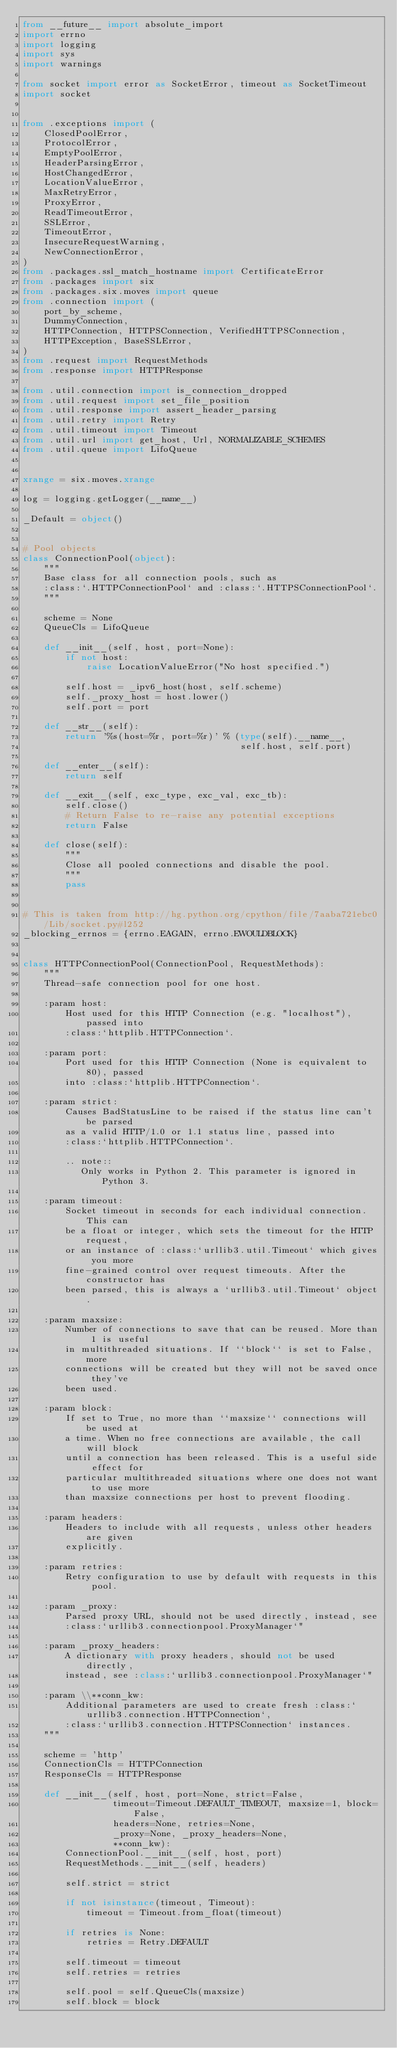<code> <loc_0><loc_0><loc_500><loc_500><_Python_>from __future__ import absolute_import
import errno
import logging
import sys
import warnings

from socket import error as SocketError, timeout as SocketTimeout
import socket


from .exceptions import (
    ClosedPoolError,
    ProtocolError,
    EmptyPoolError,
    HeaderParsingError,
    HostChangedError,
    LocationValueError,
    MaxRetryError,
    ProxyError,
    ReadTimeoutError,
    SSLError,
    TimeoutError,
    InsecureRequestWarning,
    NewConnectionError,
)
from .packages.ssl_match_hostname import CertificateError
from .packages import six
from .packages.six.moves import queue
from .connection import (
    port_by_scheme,
    DummyConnection,
    HTTPConnection, HTTPSConnection, VerifiedHTTPSConnection,
    HTTPException, BaseSSLError,
)
from .request import RequestMethods
from .response import HTTPResponse

from .util.connection import is_connection_dropped
from .util.request import set_file_position
from .util.response import assert_header_parsing
from .util.retry import Retry
from .util.timeout import Timeout
from .util.url import get_host, Url, NORMALIZABLE_SCHEMES
from .util.queue import LifoQueue


xrange = six.moves.xrange

log = logging.getLogger(__name__)

_Default = object()


# Pool objects
class ConnectionPool(object):
    """
    Base class for all connection pools, such as
    :class:`.HTTPConnectionPool` and :class:`.HTTPSConnectionPool`.
    """

    scheme = None
    QueueCls = LifoQueue

    def __init__(self, host, port=None):
        if not host:
            raise LocationValueError("No host specified.")

        self.host = _ipv6_host(host, self.scheme)
        self._proxy_host = host.lower()
        self.port = port

    def __str__(self):
        return '%s(host=%r, port=%r)' % (type(self).__name__,
                                         self.host, self.port)

    def __enter__(self):
        return self

    def __exit__(self, exc_type, exc_val, exc_tb):
        self.close()
        # Return False to re-raise any potential exceptions
        return False

    def close(self):
        """
        Close all pooled connections and disable the pool.
        """
        pass


# This is taken from http://hg.python.org/cpython/file/7aaba721ebc0/Lib/socket.py#l252
_blocking_errnos = {errno.EAGAIN, errno.EWOULDBLOCK}


class HTTPConnectionPool(ConnectionPool, RequestMethods):
    """
    Thread-safe connection pool for one host.

    :param host:
        Host used for this HTTP Connection (e.g. "localhost"), passed into
        :class:`httplib.HTTPConnection`.

    :param port:
        Port used for this HTTP Connection (None is equivalent to 80), passed
        into :class:`httplib.HTTPConnection`.

    :param strict:
        Causes BadStatusLine to be raised if the status line can't be parsed
        as a valid HTTP/1.0 or 1.1 status line, passed into
        :class:`httplib.HTTPConnection`.

        .. note::
           Only works in Python 2. This parameter is ignored in Python 3.

    :param timeout:
        Socket timeout in seconds for each individual connection. This can
        be a float or integer, which sets the timeout for the HTTP request,
        or an instance of :class:`urllib3.util.Timeout` which gives you more
        fine-grained control over request timeouts. After the constructor has
        been parsed, this is always a `urllib3.util.Timeout` object.

    :param maxsize:
        Number of connections to save that can be reused. More than 1 is useful
        in multithreaded situations. If ``block`` is set to False, more
        connections will be created but they will not be saved once they've
        been used.

    :param block:
        If set to True, no more than ``maxsize`` connections will be used at
        a time. When no free connections are available, the call will block
        until a connection has been released. This is a useful side effect for
        particular multithreaded situations where one does not want to use more
        than maxsize connections per host to prevent flooding.

    :param headers:
        Headers to include with all requests, unless other headers are given
        explicitly.

    :param retries:
        Retry configuration to use by default with requests in this pool.

    :param _proxy:
        Parsed proxy URL, should not be used directly, instead, see
        :class:`urllib3.connectionpool.ProxyManager`"

    :param _proxy_headers:
        A dictionary with proxy headers, should not be used directly,
        instead, see :class:`urllib3.connectionpool.ProxyManager`"

    :param \\**conn_kw:
        Additional parameters are used to create fresh :class:`urllib3.connection.HTTPConnection`,
        :class:`urllib3.connection.HTTPSConnection` instances.
    """

    scheme = 'http'
    ConnectionCls = HTTPConnection
    ResponseCls = HTTPResponse

    def __init__(self, host, port=None, strict=False,
                 timeout=Timeout.DEFAULT_TIMEOUT, maxsize=1, block=False,
                 headers=None, retries=None,
                 _proxy=None, _proxy_headers=None,
                 **conn_kw):
        ConnectionPool.__init__(self, host, port)
        RequestMethods.__init__(self, headers)

        self.strict = strict

        if not isinstance(timeout, Timeout):
            timeout = Timeout.from_float(timeout)

        if retries is None:
            retries = Retry.DEFAULT

        self.timeout = timeout
        self.retries = retries

        self.pool = self.QueueCls(maxsize)
        self.block = block
</code> 